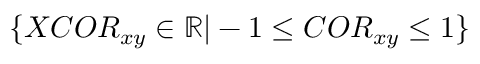Convert formula to latex. <formula><loc_0><loc_0><loc_500><loc_500>\{ X C O R _ { x y } \in \mathbb { R } | - 1 \leq C O R _ { x y } \leq 1 \}</formula> 